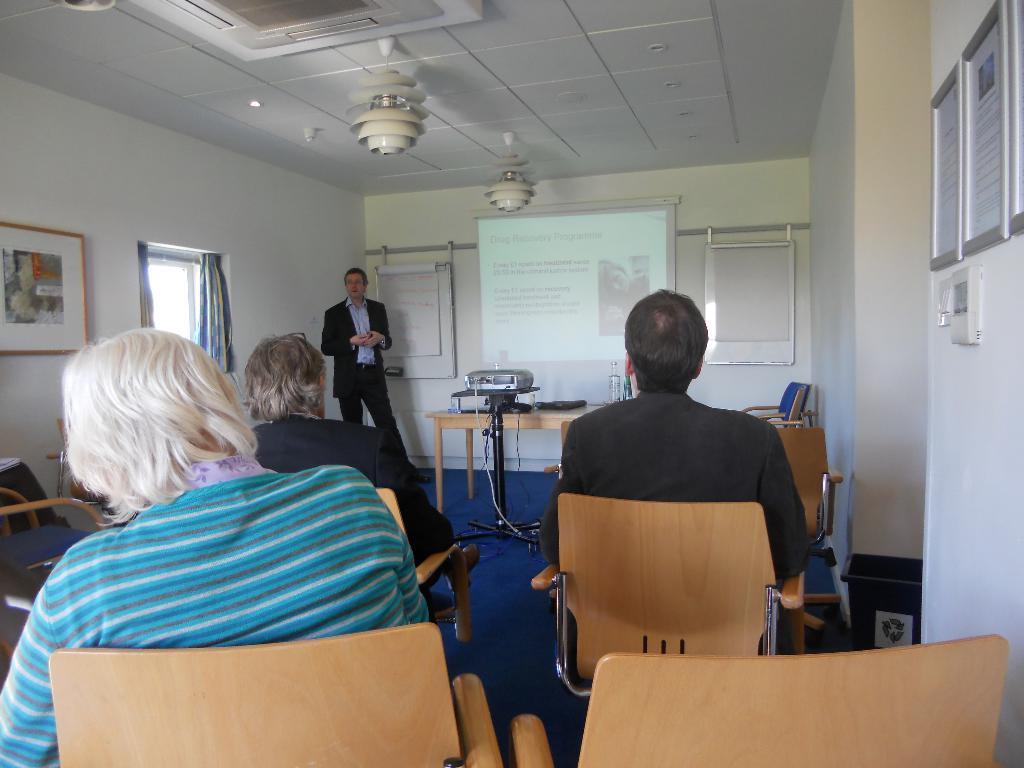Could you give a brief overview of what you see in this image? In this image, There are some chairs which are in yellow color and there are some people sitting on the chair and in the left side there is a man standing and in the middle there is a projector in white color and in the top there is a roof which is in white color. 